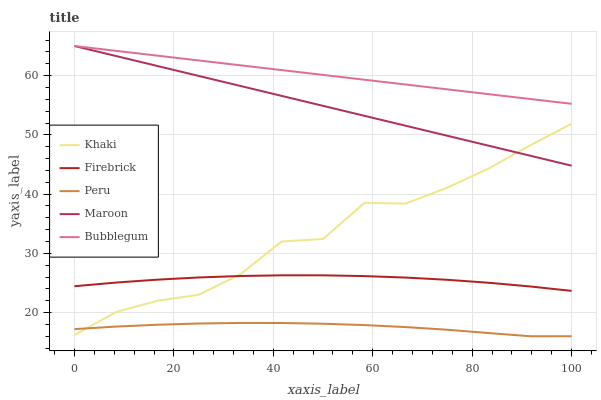Does Peru have the minimum area under the curve?
Answer yes or no. Yes. Does Bubblegum have the maximum area under the curve?
Answer yes or no. Yes. Does Khaki have the minimum area under the curve?
Answer yes or no. No. Does Khaki have the maximum area under the curve?
Answer yes or no. No. Is Bubblegum the smoothest?
Answer yes or no. Yes. Is Khaki the roughest?
Answer yes or no. Yes. Is Khaki the smoothest?
Answer yes or no. No. Is Bubblegum the roughest?
Answer yes or no. No. Does Khaki have the lowest value?
Answer yes or no. No. Does Maroon have the highest value?
Answer yes or no. Yes. Does Khaki have the highest value?
Answer yes or no. No. Is Peru less than Bubblegum?
Answer yes or no. Yes. Is Bubblegum greater than Khaki?
Answer yes or no. Yes. Does Maroon intersect Bubblegum?
Answer yes or no. Yes. Is Maroon less than Bubblegum?
Answer yes or no. No. Is Maroon greater than Bubblegum?
Answer yes or no. No. Does Peru intersect Bubblegum?
Answer yes or no. No. 